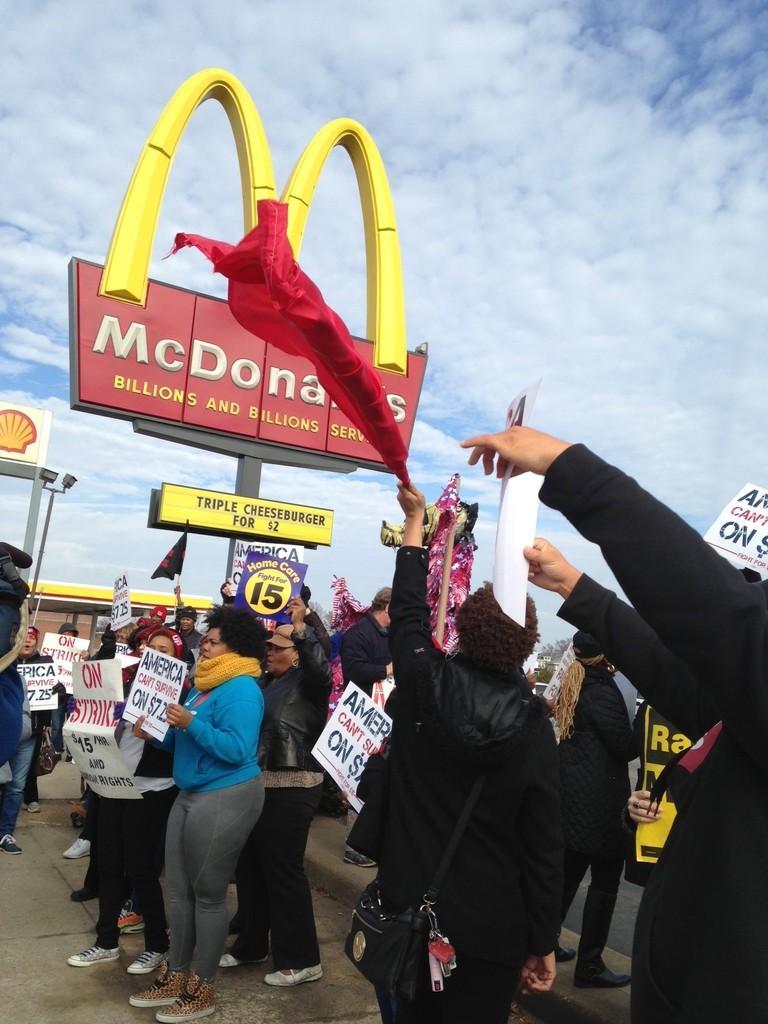Please provide a concise description of this image. In the picture we can see some people are standing and holding some boards and something written on it and besides them, we can see an MC Donald board and on the poles and Yellow color M symbol on it and we can also see a sky with clouds. 